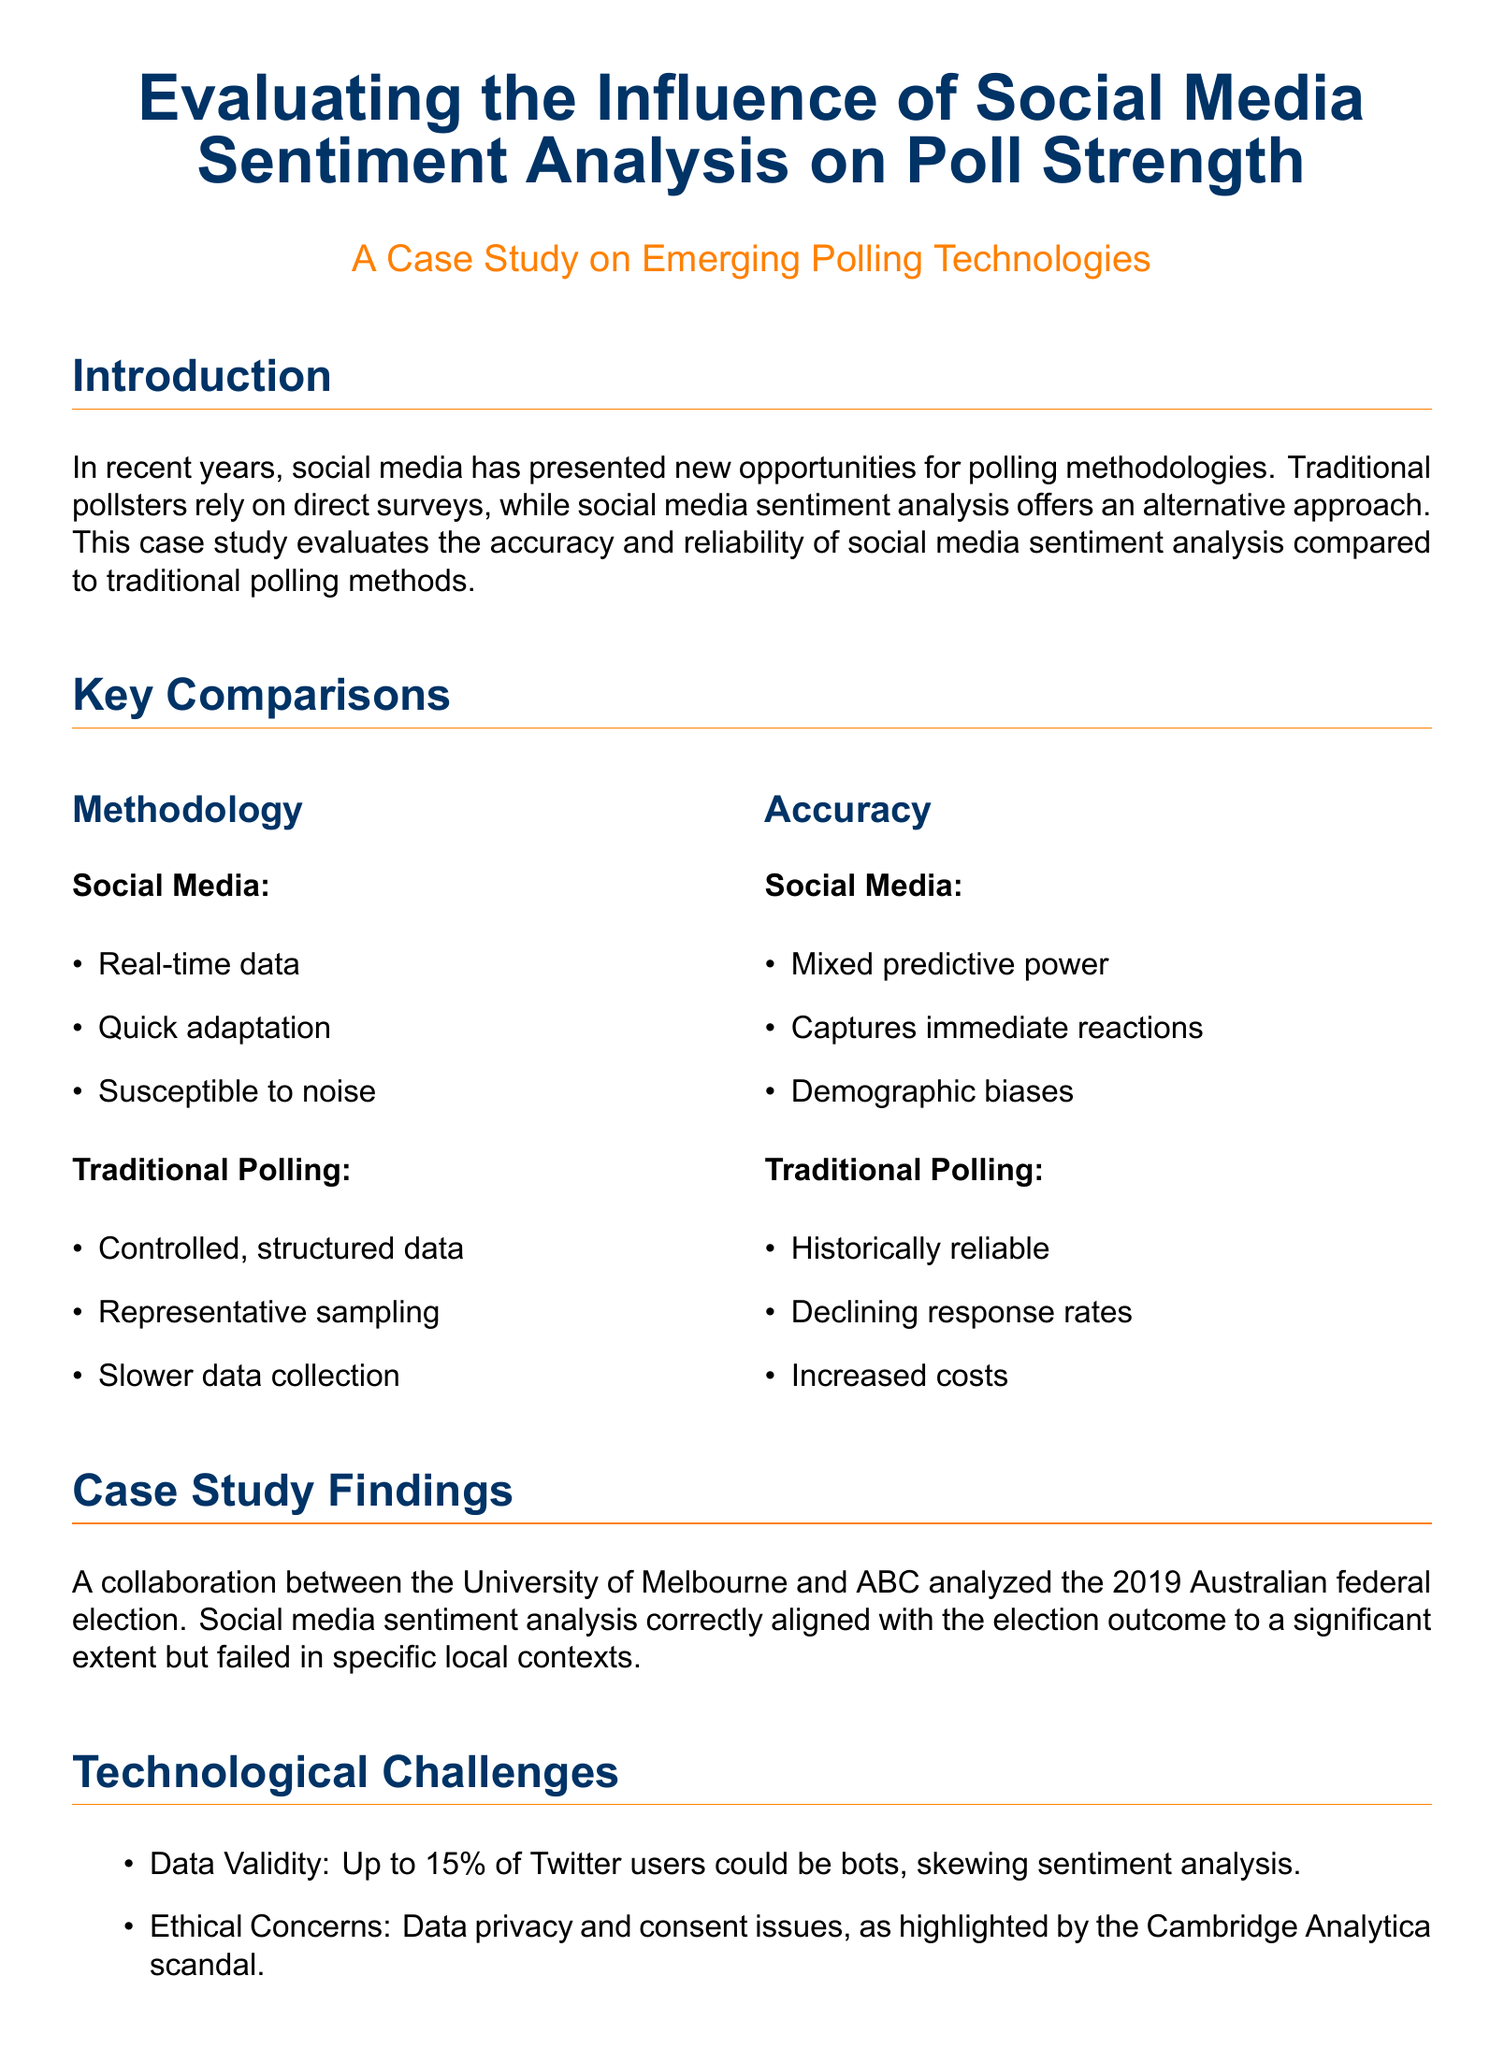What are the two approaches to polling mentioned? The document lists traditional polling methods and social media sentiment analysis as the two approaches to polling.
Answer: traditional polling methods and social media sentiment analysis What was the percentage of Twitter users that could potentially be bots? The case study mentions that up to 15% of Twitter users could be bots, which can affect the validity of sentiment analysis.
Answer: 15% Which organization collaborated with the University of Melbourne in the case study? The case study refers to a collaboration between the University of Melbourne and ABC for analyzing the election outcomes.
Answer: ABC What year did the analyzed election take place? The document specifies that the findings were based on the analysis of the 2019 Australian federal election.
Answer: 2019 What is one significant limitation of social media sentiment analysis mentioned? The document highlights demographic biases as a notable limitation of social media sentiment analysis.
Answer: demographic biases What hybrid model does Ipsos use? The case study states that Ipsos has developed mixed-method approaches that combine online sentiment analysis with structured polling.
Answer: Online sentiment analysis with structured polling What was the outcome alignment of social media sentiment analysis regarding the election? The case study found that social media sentiment analysis aligned correctly with the election outcome to a significant extent.
Answer: correctly aligned What is one ethical concern mentioned in the report? The report mentions data privacy and consent issues as significant ethical concerns surrounding social media sentiment analysis.
Answer: Data privacy and consent issues 